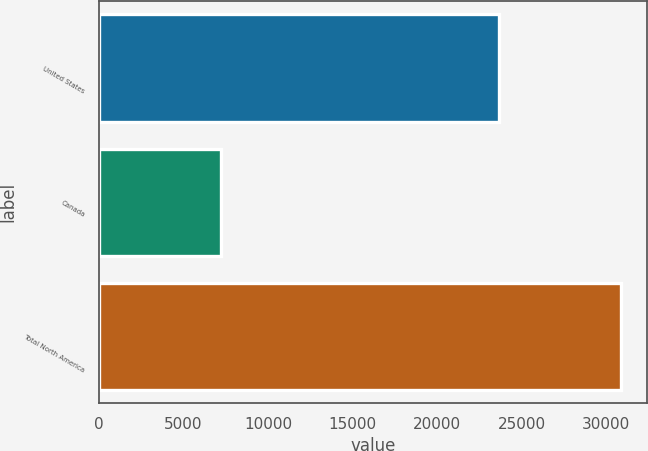<chart> <loc_0><loc_0><loc_500><loc_500><bar_chart><fcel>United States<fcel>Canada<fcel>Total North America<nl><fcel>23640<fcel>7222<fcel>30862<nl></chart> 